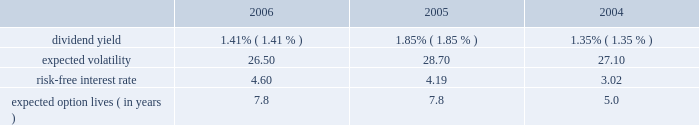For the year ended december 31 , 2005 , we realized net losses of $ 1 million on sales of available-for- sale securities .
Unrealized gains of $ 1 million were included in other comprehensive income at december 31 , 2004 , net of deferred taxes of less than $ 1 million , related to these sales .
For the year ended december 31 , 2004 , we realized net gains of $ 26 million on sales of available-for- sale securities .
Unrealized gains of $ 11 million were included in other comprehensive income at december 31 , 2003 , net of deferred taxes of $ 7 million , related to these sales .
Note 13 .
Equity-based compensation the 2006 equity incentive plan was approved by shareholders in april 2006 , and 20000000 shares of common stock were approved for issuance for stock and stock-based awards , including stock options , stock appreciation rights , restricted stock , deferred stock and performance awards .
In addition , up to 8000000 shares from our 1997 equity incentive plan , that were available to issue or become available due to cancellations and forfeitures , may be awarded under the 2006 plan .
The 1997 plan expired on december 18 , 2006 .
As of december 31 , 2006 , 1305420 shares from the 1997 plan have been added to and may be awarded from the 2006 plan .
As of december 31 , 2006 , 106045 awards have been made under the 2006 plan .
We have stock options outstanding from previous plans , including the 1997 plan , under which no further grants can be made .
The exercise price of non-qualified and incentive stock options and stock appreciation rights may not be less than the fair value of such shares at the date of grant .
Stock options and stock appreciation rights issued under the 2006 plan and the prior 1997 plan generally vest over four years and expire no later than ten years from the date of grant .
For restricted stock awards issued under the 2006 plan and the prior 1997 plan , stock certificates are issued at the time of grant and recipients have dividend and voting rights .
In general , these grants vest over three years .
For deferred stock awards issued under the 2006 plan and the prior 1997 plan , no stock is issued at the time of grant .
Generally , these grants vest over two- , three- or four-year periods .
Performance awards granted under the 2006 equity incentive plan and the prior 1997 plan are earned over a performance period based on achievement of goals , generally over two- to three- year periods .
Payment for performance awards is made in shares of our common stock or in cash equal to the fair market value of our common stock , based on certain financial ratios after the conclusion of each performance period .
We record compensation expense , equal to the estimated fair value of the options on the grant date , on a straight-line basis over the options 2019 vesting period .
We use a black-scholes option-pricing model to estimate the fair value of the options granted .
The weighted-average assumptions used in connection with the option-pricing model were as follows for the years indicated. .
Compensation expense related to stock options , stock appreciation rights , restricted stock awards , deferred stock awards and performance awards , which we record as a component of salaries and employee benefits expense in our consolidated statement of income , was $ 208 million , $ 110 million and $ 74 million for the years ended december 31 , 2006 , 2005 and 2004 , respectively .
The related total income tax benefit recorded in our consolidated statement of income was $ 83 million , $ 44 million and $ 30 million for 2006 , 2005 and 2004 , respectively .
Seq 87 copyarea : 38 .
X 54 .
Trimsize : 8.25 x 10.75 typeset state street corporation serverprocess c:\\fc\\delivery_1024177\\2771-1-do_p.pdf chksum : 0 cycle 1merrill corporation 07-2771-1 thu mar 01 17:11:13 2007 ( v 2.247w--stp1pae18 ) .
What is the growth rate in the risk-free interest rate from 2005 to 2006? 
Computations: ((4.60 - 4.19) / 4.19)
Answer: 0.09785. For the year ended december 31 , 2005 , we realized net losses of $ 1 million on sales of available-for- sale securities .
Unrealized gains of $ 1 million were included in other comprehensive income at december 31 , 2004 , net of deferred taxes of less than $ 1 million , related to these sales .
For the year ended december 31 , 2004 , we realized net gains of $ 26 million on sales of available-for- sale securities .
Unrealized gains of $ 11 million were included in other comprehensive income at december 31 , 2003 , net of deferred taxes of $ 7 million , related to these sales .
Note 13 .
Equity-based compensation the 2006 equity incentive plan was approved by shareholders in april 2006 , and 20000000 shares of common stock were approved for issuance for stock and stock-based awards , including stock options , stock appreciation rights , restricted stock , deferred stock and performance awards .
In addition , up to 8000000 shares from our 1997 equity incentive plan , that were available to issue or become available due to cancellations and forfeitures , may be awarded under the 2006 plan .
The 1997 plan expired on december 18 , 2006 .
As of december 31 , 2006 , 1305420 shares from the 1997 plan have been added to and may be awarded from the 2006 plan .
As of december 31 , 2006 , 106045 awards have been made under the 2006 plan .
We have stock options outstanding from previous plans , including the 1997 plan , under which no further grants can be made .
The exercise price of non-qualified and incentive stock options and stock appreciation rights may not be less than the fair value of such shares at the date of grant .
Stock options and stock appreciation rights issued under the 2006 plan and the prior 1997 plan generally vest over four years and expire no later than ten years from the date of grant .
For restricted stock awards issued under the 2006 plan and the prior 1997 plan , stock certificates are issued at the time of grant and recipients have dividend and voting rights .
In general , these grants vest over three years .
For deferred stock awards issued under the 2006 plan and the prior 1997 plan , no stock is issued at the time of grant .
Generally , these grants vest over two- , three- or four-year periods .
Performance awards granted under the 2006 equity incentive plan and the prior 1997 plan are earned over a performance period based on achievement of goals , generally over two- to three- year periods .
Payment for performance awards is made in shares of our common stock or in cash equal to the fair market value of our common stock , based on certain financial ratios after the conclusion of each performance period .
We record compensation expense , equal to the estimated fair value of the options on the grant date , on a straight-line basis over the options 2019 vesting period .
We use a black-scholes option-pricing model to estimate the fair value of the options granted .
The weighted-average assumptions used in connection with the option-pricing model were as follows for the years indicated. .
Compensation expense related to stock options , stock appreciation rights , restricted stock awards , deferred stock awards and performance awards , which we record as a component of salaries and employee benefits expense in our consolidated statement of income , was $ 208 million , $ 110 million and $ 74 million for the years ended december 31 , 2006 , 2005 and 2004 , respectively .
The related total income tax benefit recorded in our consolidated statement of income was $ 83 million , $ 44 million and $ 30 million for 2006 , 2005 and 2004 , respectively .
Seq 87 copyarea : 38 .
X 54 .
Trimsize : 8.25 x 10.75 typeset state street corporation serverprocess c:\\fc\\delivery_1024177\\2771-1-do_p.pdf chksum : 0 cycle 1merrill corporation 07-2771-1 thu mar 01 17:11:13 2007 ( v 2.247w--stp1pae18 ) .
What percent did the employee benefits expense increase between 2004 and 2006? 
Computations: ((208 - 74) / 74)
Answer: 1.81081. 